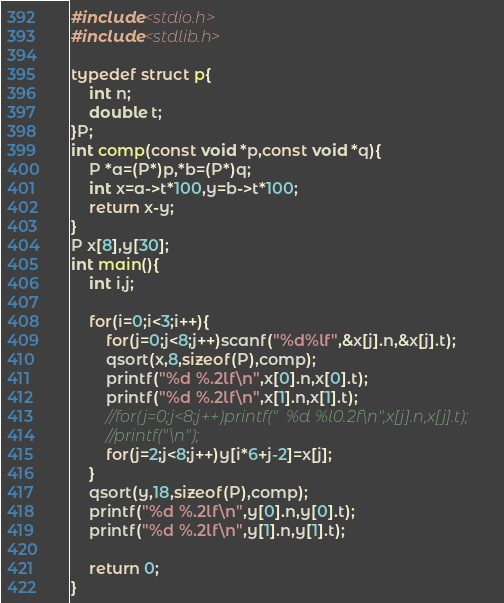Convert code to text. <code><loc_0><loc_0><loc_500><loc_500><_C_>#include<stdio.h>
#include<stdlib.h>

typedef struct p{
	int n;
	double t;
}P;
int comp(const void *p,const void *q){
	P *a=(P*)p,*b=(P*)q;
	int x=a->t*100,y=b->t*100;
	return x-y;
}
P x[8],y[30];
int main(){
	int i,j;
	
	for(i=0;i<3;i++){
		for(j=0;j<8;j++)scanf("%d%lf",&x[j].n,&x[j].t);
		qsort(x,8,sizeof(P),comp);
		printf("%d %.2lf\n",x[0].n,x[0].t);
		printf("%d %.2lf\n",x[1].n,x[1].t);
		//for(j=0;j<8;j++)printf("  %d %l0.2f\n",x[j].n,x[j].t);
		//printf("\n");
		for(j=2;j<8;j++)y[i*6+j-2]=x[j];
	}
	qsort(y,18,sizeof(P),comp);
	printf("%d %.2lf\n",y[0].n,y[0].t);
	printf("%d %.2lf\n",y[1].n,y[1].t);
		
	return 0;
}</code> 